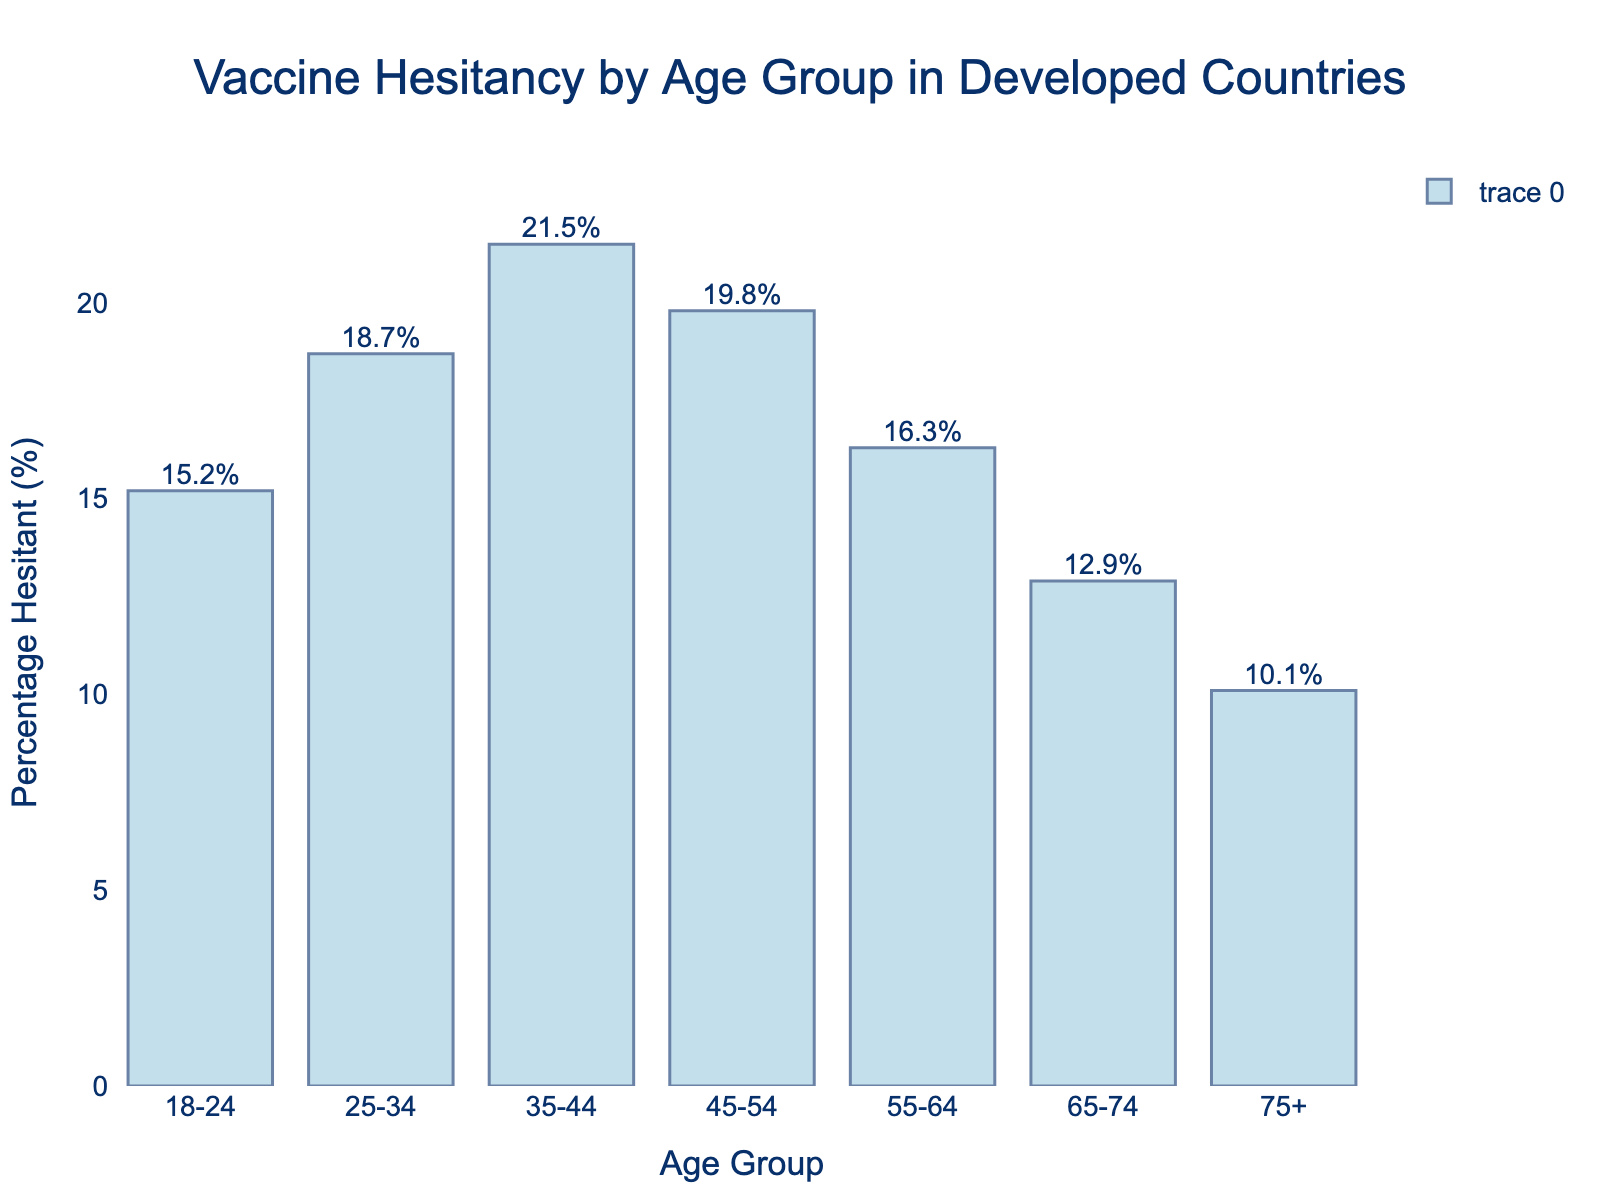Which age group has the highest percentage of vaccine hesitancy? From the figure, the bar representing the 35-44 age group is the tallest, indicating it has the highest percentage of vaccine hesitancy.
Answer: 35-44 Which age group has the lowest percentage of vaccine hesitancy? From the figure, the bar representing the 75+ age group is the shortest, indicating it has the lowest percentage of vaccine hesitancy.
Answer: 75+ What is the difference in vaccine hesitancy between the 25-34 and 65-74 age groups? From the figure, the percentage hesitancy for the 25-34 age group is 18.7%, and for the 65-74 age group, it is 12.9%. The difference is 18.7% - 12.9% = 5.8%.
Answer: 5.8% Which age group has a vaccine hesitancy percentage closer to 20%? From the figure, the 35-44 age group has a vaccine hesitancy percentage of 21.5%, which is closest to 20%.
Answer: 35-44 Rank the age groups in descending order of their vaccine hesitancy percentages. From the figure, the order from highest to lowest is: 35-44 (21.5%), 45-54 (19.8%), 25-34 (18.7%), 55-64 (16.3%), 18-24 (15.2%), 65-74 (12.9%), 75+ (10.1%).
Answer: 35-44, 45-54, 25-34, 55-64, 18-24, 65-74, 75+ What is the average vaccine hesitancy percentage across all age groups? From the figure, sum the percentages: 15.2% + 18.7% + 21.5% + 19.8% + 16.3% + 12.9% + 10.1% = 114.5%. There are 7 age groups, so the average is 114.5% / 7 ≈ 16.36%.
Answer: 16.36% What is the range of vaccine hesitancy percentages across all age groups? From the figure, the highest percentage is 21.5% (35-44) and the lowest percentage is 10.1% (75+). The range is 21.5% - 10.1% = 11.4%.
Answer: 11.4% Is the vaccine hesitancy percentage for the 18-24 age group greater than that for the 55-64 age group? From the figure, the vaccine hesitancy percentage for the 18-24 age group is 15.2%, and for the 55-64 age group, it is 16.3%. Hence, 15.2% is not greater than 16.3%.
Answer: No 